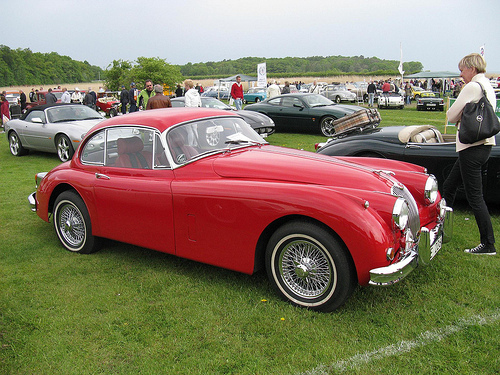<image>
Can you confirm if the grass is on the car? No. The grass is not positioned on the car. They may be near each other, but the grass is not supported by or resting on top of the car. 